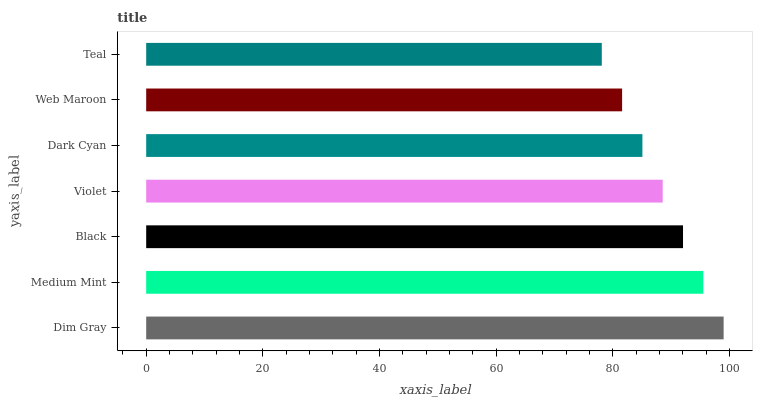Is Teal the minimum?
Answer yes or no. Yes. Is Dim Gray the maximum?
Answer yes or no. Yes. Is Medium Mint the minimum?
Answer yes or no. No. Is Medium Mint the maximum?
Answer yes or no. No. Is Dim Gray greater than Medium Mint?
Answer yes or no. Yes. Is Medium Mint less than Dim Gray?
Answer yes or no. Yes. Is Medium Mint greater than Dim Gray?
Answer yes or no. No. Is Dim Gray less than Medium Mint?
Answer yes or no. No. Is Violet the high median?
Answer yes or no. Yes. Is Violet the low median?
Answer yes or no. Yes. Is Black the high median?
Answer yes or no. No. Is Medium Mint the low median?
Answer yes or no. No. 